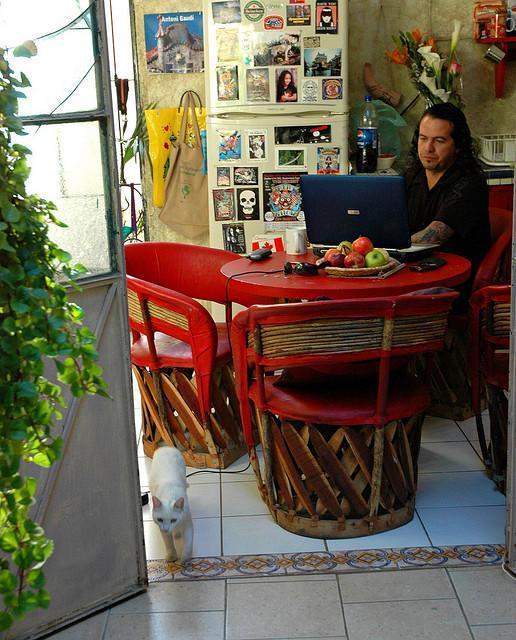How many chairs are in the picture?
Give a very brief answer. 3. How many cats are in the picture?
Give a very brief answer. 1. How many rolls of toilet paper are there?
Give a very brief answer. 0. 